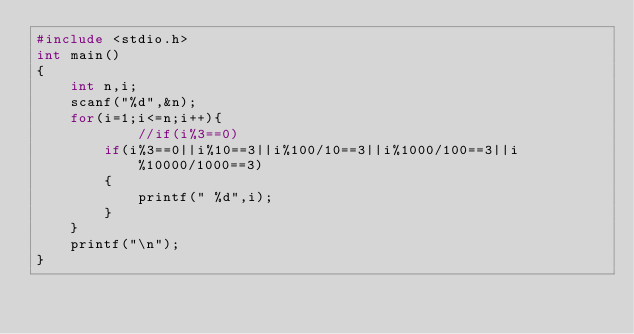<code> <loc_0><loc_0><loc_500><loc_500><_C_>#include <stdio.h>
int main()
{
	int n,i;
	scanf("%d",&n);
	for(i=1;i<=n;i++){
            //if(i%3==0)
		if(i%3==0||i%10==3||i%100/10==3||i%1000/100==3||i%10000/1000==3)
		{
			printf(" %d",i);
	    }
	}
	printf("\n");
}

</code> 